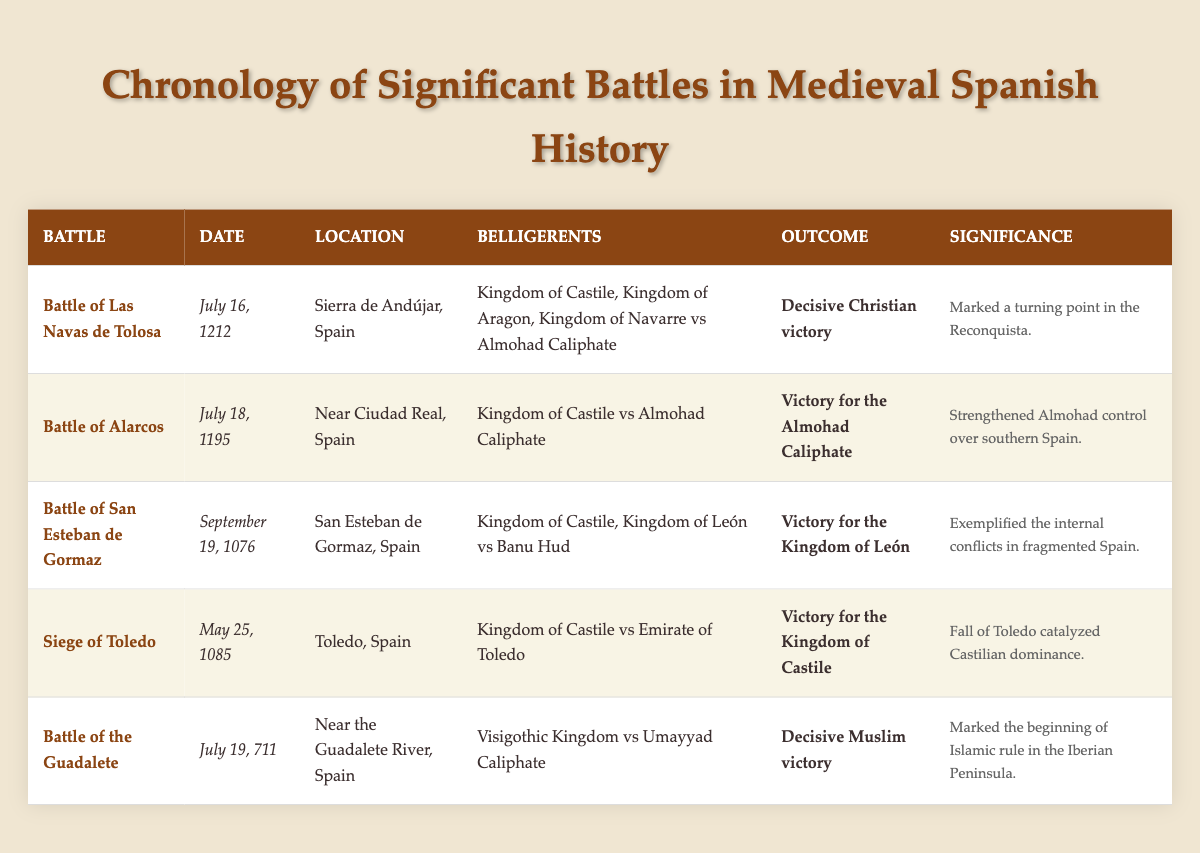What battle occurred on July 16, 1212? Referring to the table, the battle listed on this date is the Battle of Las Navas de Tolosa.
Answer: Battle of Las Navas de Tolosa Which belligerents were involved in the Battle of Alarcos? By checking the row for the Battle of Alarcos, the belligerents listed are the Kingdom of Castile and the Almohad Caliphate.
Answer: Kingdom of Castile, Almohad Caliphate What was the outcome of the Siege of Toledo? Looking at the Siege of Toledo entry in the table, the outcome stated is a victory for the Kingdom of Castile.
Answer: Victory for the Kingdom of Castile Did the Battle of the Guadalete have a Christian victory? According to the data presented in the table, the outcome of the Battle of the Guadalete was a decisive Muslim victory, so this statement is false.
Answer: No Which battle marked the beginning of Islamic rule in the Iberian Peninsula? The table indicates that the Battle of the Guadalete was significant for marking the beginning of Islamic rule in the Iberian Peninsula.
Answer: Battle of the Guadalete Which two battles resulted in a victory for the Kingdom of Castile? By examining the table, the two battles where the Kingdom of Castile achieved victory are the Siege of Toledo and the Battle of Las Navas de Tolosa.
Answer: Siege of Toledo, Battle of Las Navas de Tolosa What is the average year of the battles listed in the table? First, we note the years of the battles: 1212, 1195, 1076, 1085, and 711. Adding these gives 1212 + 1195 + 1076 + 1085 + 711 = 5279. There are 5 battles, so the average year is 5279 / 5 = 1055.8, which we round to 1056.
Answer: 1056 How many battles involved the Kingdom of Castile? In the table, we can see that the Kingdom of Castile is listed in four battles: the Battle of Las Navas de Tolosa, the Battle of Alarcos, the Battle of San Esteban de Gormaz, and the Siege of Toledo. Thus, there are four battles involving the Kingdom of Castile.
Answer: 4 Was the Battle of San Esteban de Gormaz fought against the Almohad Caliphate? The table shows that the Battle of San Esteban de Gormaz involved the Kingdom of Castile, Kingdom of León, and Banu Hud, but not the Almohad Caliphate. Therefore, this statement is false.
Answer: No 